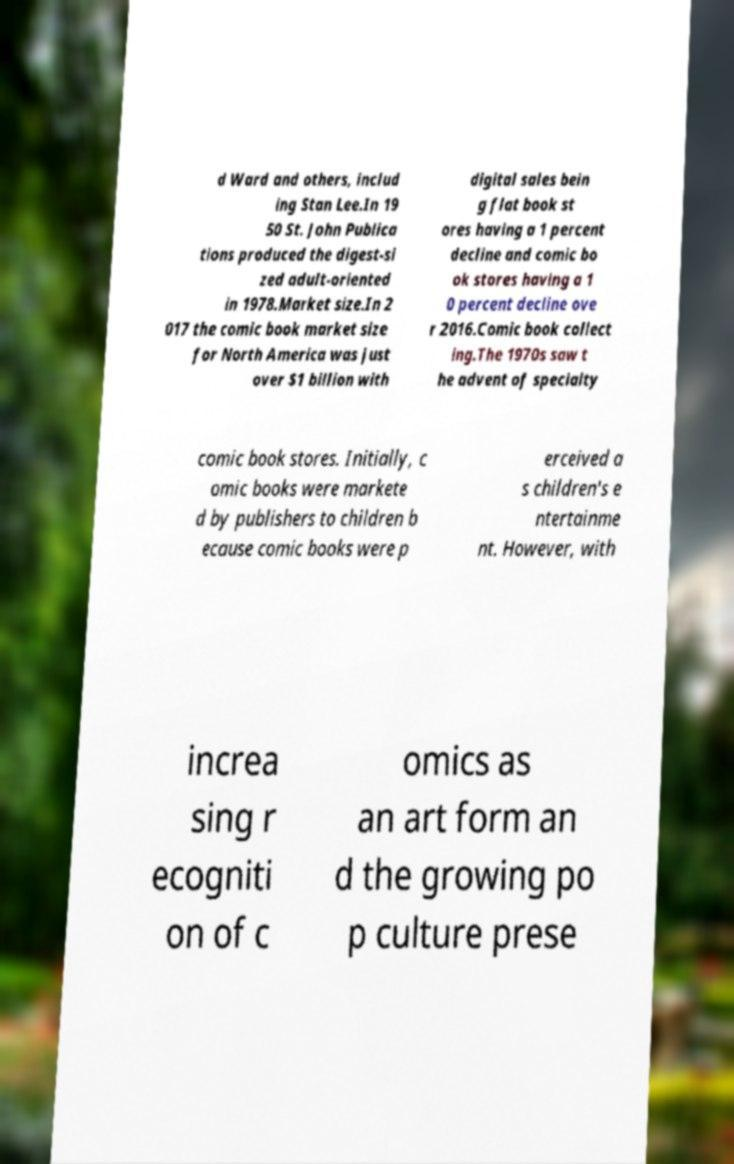Could you extract and type out the text from this image? d Ward and others, includ ing Stan Lee.In 19 50 St. John Publica tions produced the digest-si zed adult-oriented in 1978.Market size.In 2 017 the comic book market size for North America was just over $1 billion with digital sales bein g flat book st ores having a 1 percent decline and comic bo ok stores having a 1 0 percent decline ove r 2016.Comic book collect ing.The 1970s saw t he advent of specialty comic book stores. Initially, c omic books were markete d by publishers to children b ecause comic books were p erceived a s children's e ntertainme nt. However, with increa sing r ecogniti on of c omics as an art form an d the growing po p culture prese 